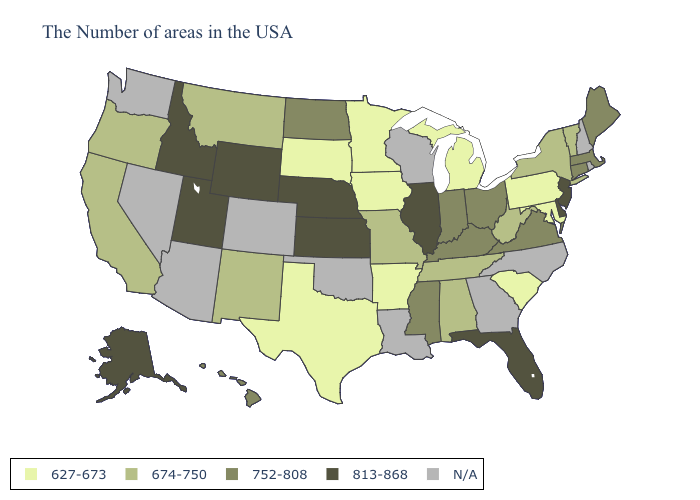Name the states that have a value in the range 674-750?
Be succinct. Vermont, New York, West Virginia, Alabama, Tennessee, Missouri, New Mexico, Montana, California, Oregon. What is the value of New Jersey?
Concise answer only. 813-868. Name the states that have a value in the range 813-868?
Keep it brief. New Jersey, Delaware, Florida, Illinois, Kansas, Nebraska, Wyoming, Utah, Idaho, Alaska. Is the legend a continuous bar?
Keep it brief. No. What is the lowest value in states that border Colorado?
Answer briefly. 674-750. How many symbols are there in the legend?
Quick response, please. 5. Name the states that have a value in the range 752-808?
Answer briefly. Maine, Massachusetts, Connecticut, Virginia, Ohio, Kentucky, Indiana, Mississippi, North Dakota, Hawaii. Name the states that have a value in the range N/A?
Quick response, please. Rhode Island, New Hampshire, North Carolina, Georgia, Wisconsin, Louisiana, Oklahoma, Colorado, Arizona, Nevada, Washington. What is the highest value in states that border Arizona?
Answer briefly. 813-868. Among the states that border Ohio , which have the highest value?
Be succinct. Kentucky, Indiana. Name the states that have a value in the range 813-868?
Write a very short answer. New Jersey, Delaware, Florida, Illinois, Kansas, Nebraska, Wyoming, Utah, Idaho, Alaska. Which states have the highest value in the USA?
Concise answer only. New Jersey, Delaware, Florida, Illinois, Kansas, Nebraska, Wyoming, Utah, Idaho, Alaska. What is the value of Nebraska?
Be succinct. 813-868. Which states have the highest value in the USA?
Give a very brief answer. New Jersey, Delaware, Florida, Illinois, Kansas, Nebraska, Wyoming, Utah, Idaho, Alaska. 